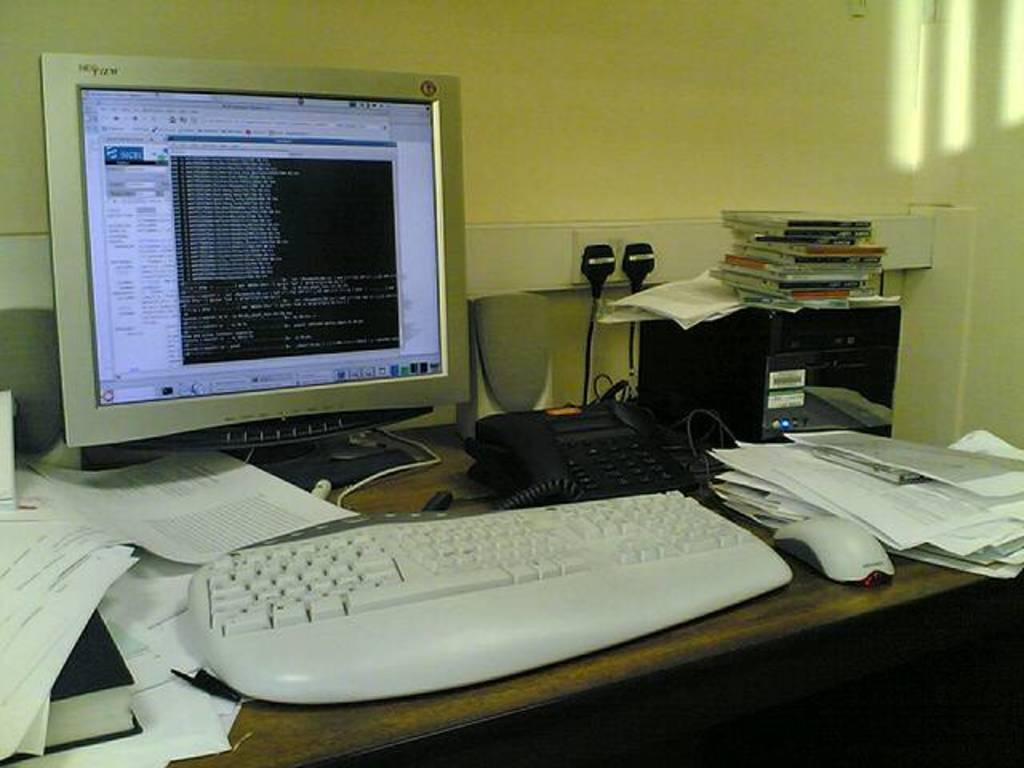What is the main piece of furniture in the image? There is a table in the image. What items can be seen on the table? Papers, a book, a keyboard, a mouse, a telephone, and a monitor are on the table. Are there any additional electronic devices in the image? Yes, there are speakers on the table. What is the location of the CPU in the image? The CPU is aside the table. Can you describe the wall in the image? There is a wall visible in the image. Is there any other equipment related to the electronic devices in the image? Yes, there is a switch board on the wall. What type of grass can be seen growing on the table in the image? There is no grass present on the table in the image. What time of day is depicted in the image? The time of day is not mentioned or depicted in the image. 